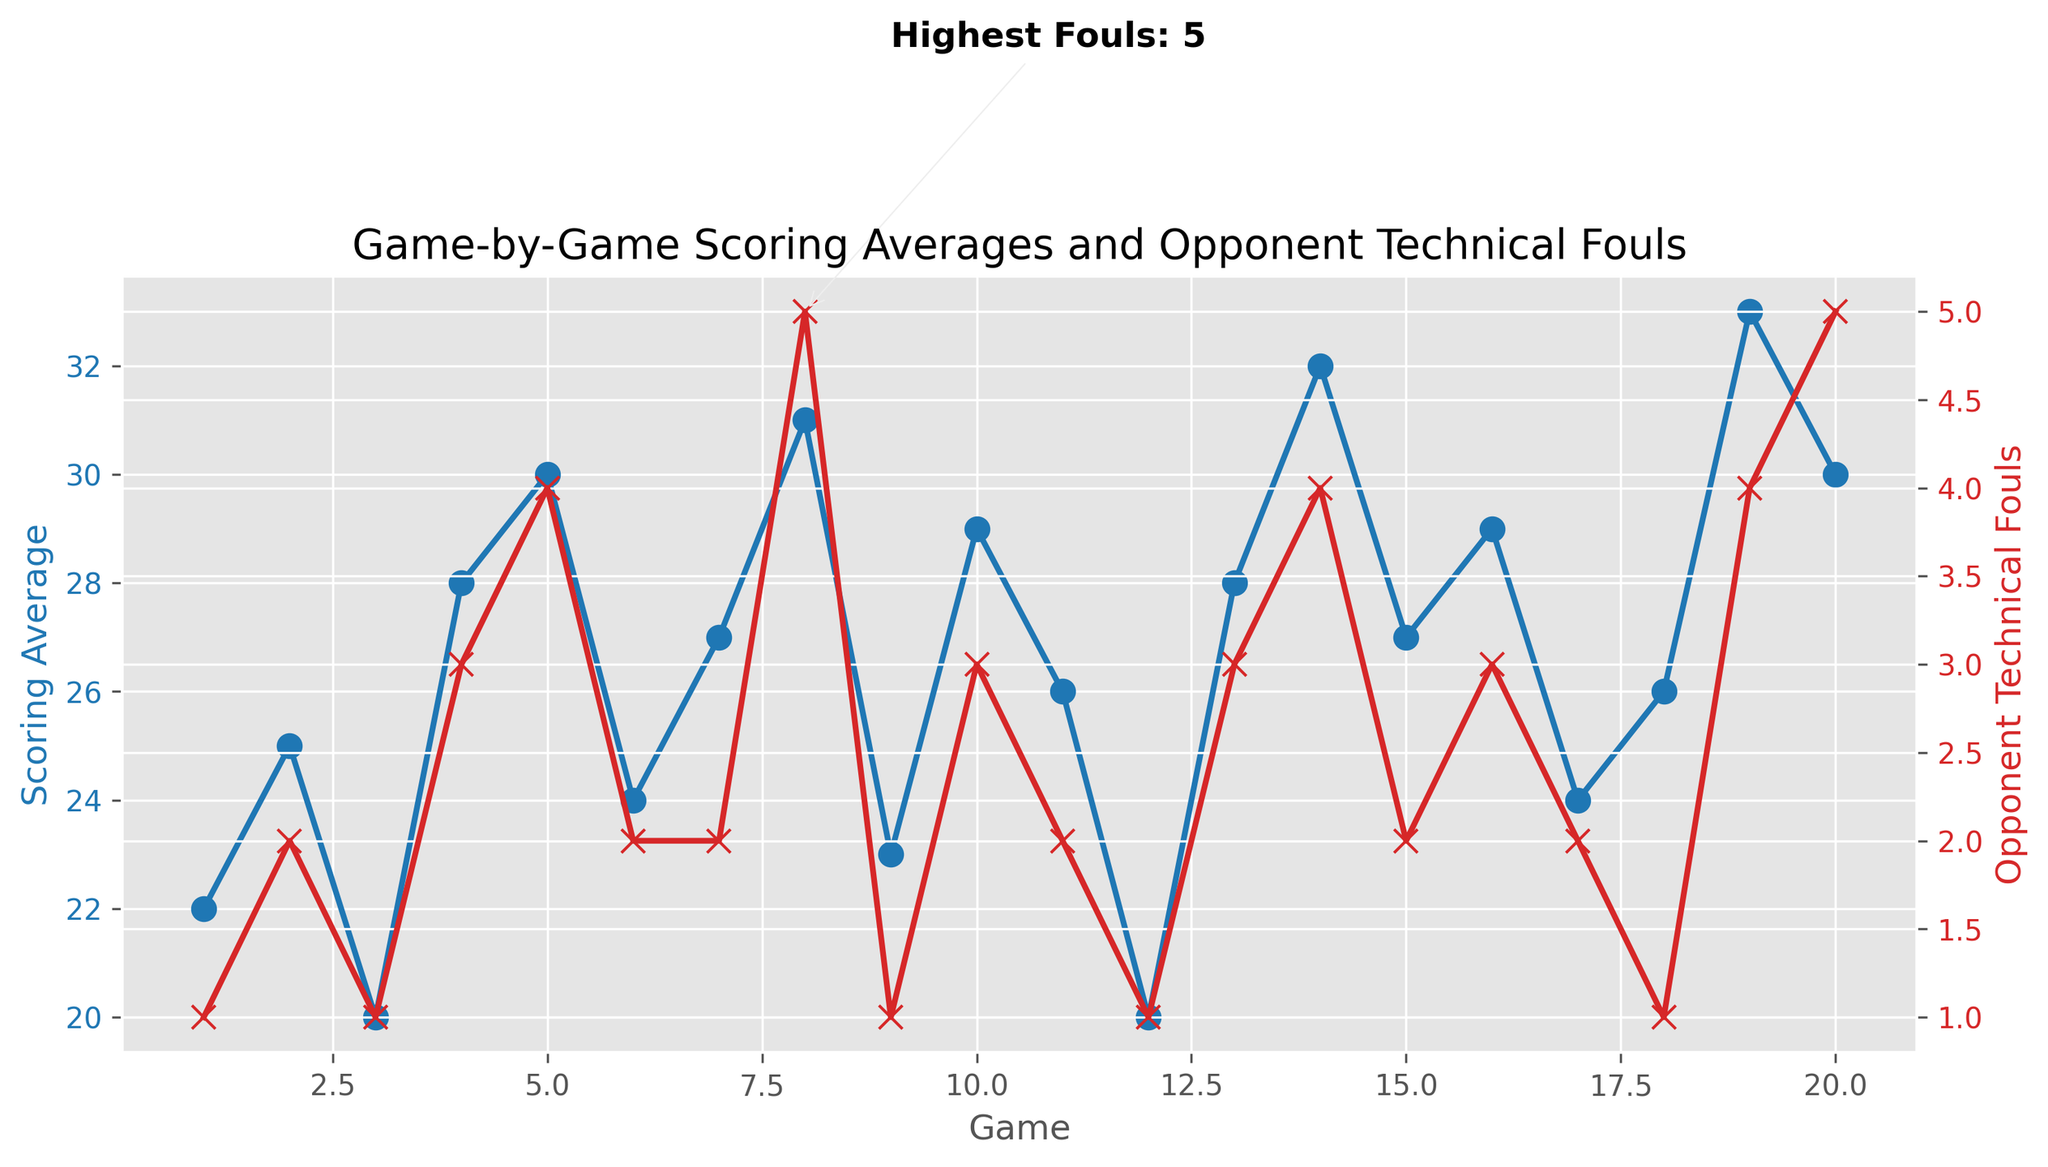What is the highest scoring average observed in the games? First, locate the "Scoring Average" line chart. Identify the peak point in terms of height since it's the highest value. Upon close inspection of the chart, you can see that the highest point reaches up to the value of 33.
Answer: 33 Which game had the highest number of opponent technical fouls? Refer to the "Opponent Technical Fouls" line chart which uses the color red. Find the maximum point in terms of height. The annotation "Highest Fouls: 5" is at Game 8, indicating this game received the most fouls.
Answer: Game 8 What is the scoring average for the game with the highest opponent technical fouls? First, locate the game with the highest technical fouls, which is Game 8 from the annotation. Next, check the scoring average at the same game by looking at the blue line. The scoring average at Game 8 is 31.
Answer: 31 What is the difference in opponent technical fouls between Game 5 and Game 6? Look at the red "Opponent Technical Fouls" line and find the values for Game 5 and Game 6, which are 4 and 2 respectively. Subtract the value at Game 6 from the value at Game 5: 4 - 2 = 2.
Answer: 2 Which game shows the lowest scoring average? Look at the blue "Scoring Average" line chart. Identify the lowest point in terms of height. This point is at Game 12 with a scoring average of 20.
Answer: Game 12 Compare the scoring averages of the first and last games. Which one is higher? Find the scoring average at Game 1 and Game 20 from the blue line chart. Game 1 has a scoring average of 22, while Game 20 has 30. Therefore, Game 20 has a higher scoring average.
Answer: Game 20 Calculate the average number of opponent technical fouls over all games. Sum the number of technical fouls across all the games (1+2+1+3+4+2+2+5+1+3+2+1+3+4+2+3+2+1+4+5 = 46) and divide by the total number of games (20). The average is 46 / 20 = 2.3.
Answer: 2.3 What is the correlation between scoring average and opponent technical fouls as observed in the plot? Visually examine the trends of both lines. When the scoring average is higher, the number of opponent technical fouls tends to be higher as well. This suggests a positive correlation.
Answer: Positive correlation Between which two consecutive games did the scoring average drop the most? Compare the "Scoring Average" values between each pair of consecutive games. The largest drop occurs between Game 5 (30) and Game 6 (24), which is a drop of 6 points.
Answer: Game 5 to Game 6 How many games have an opponent technical fouls value of 3 or higher? Look at the red line and count the number of games where the opponent technical fouls are 3 or higher. These occur at Games 4, 8, 10, 13, 14, 16, 19, and 20 (8 games).
Answer: 8 